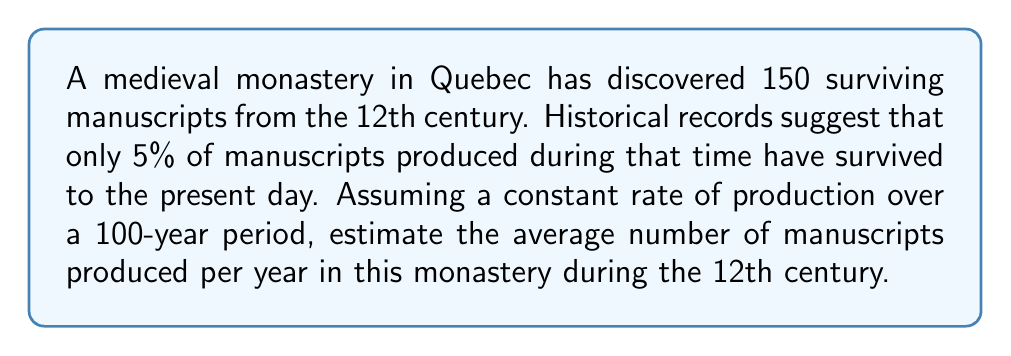Show me your answer to this math problem. Let's approach this step-by-step:

1. Define variables:
   Let $x$ be the total number of manuscripts produced in the 12th century.
   Let $y$ be the average number of manuscripts produced per year.

2. Given information:
   - 150 manuscripts have survived
   - 5% of manuscripts produced have survived
   - The production period is 100 years

3. Set up an equation:
   $150 = 0.05x$ (surviving manuscripts = 5% of total produced)

4. Solve for $x$:
   $x = \frac{150}{0.05} = 3000$

5. Calculate the average yearly production:
   $y = \frac{x}{100} = \frac{3000}{100} = 30$

Therefore, the monastery produced an average of 30 manuscripts per year during the 12th century.

This problem is an example of an inverse problem because we are using the observed data (surviving manuscripts) to estimate the original conditions (production rate) that led to this observation.
Answer: 30 manuscripts per year 